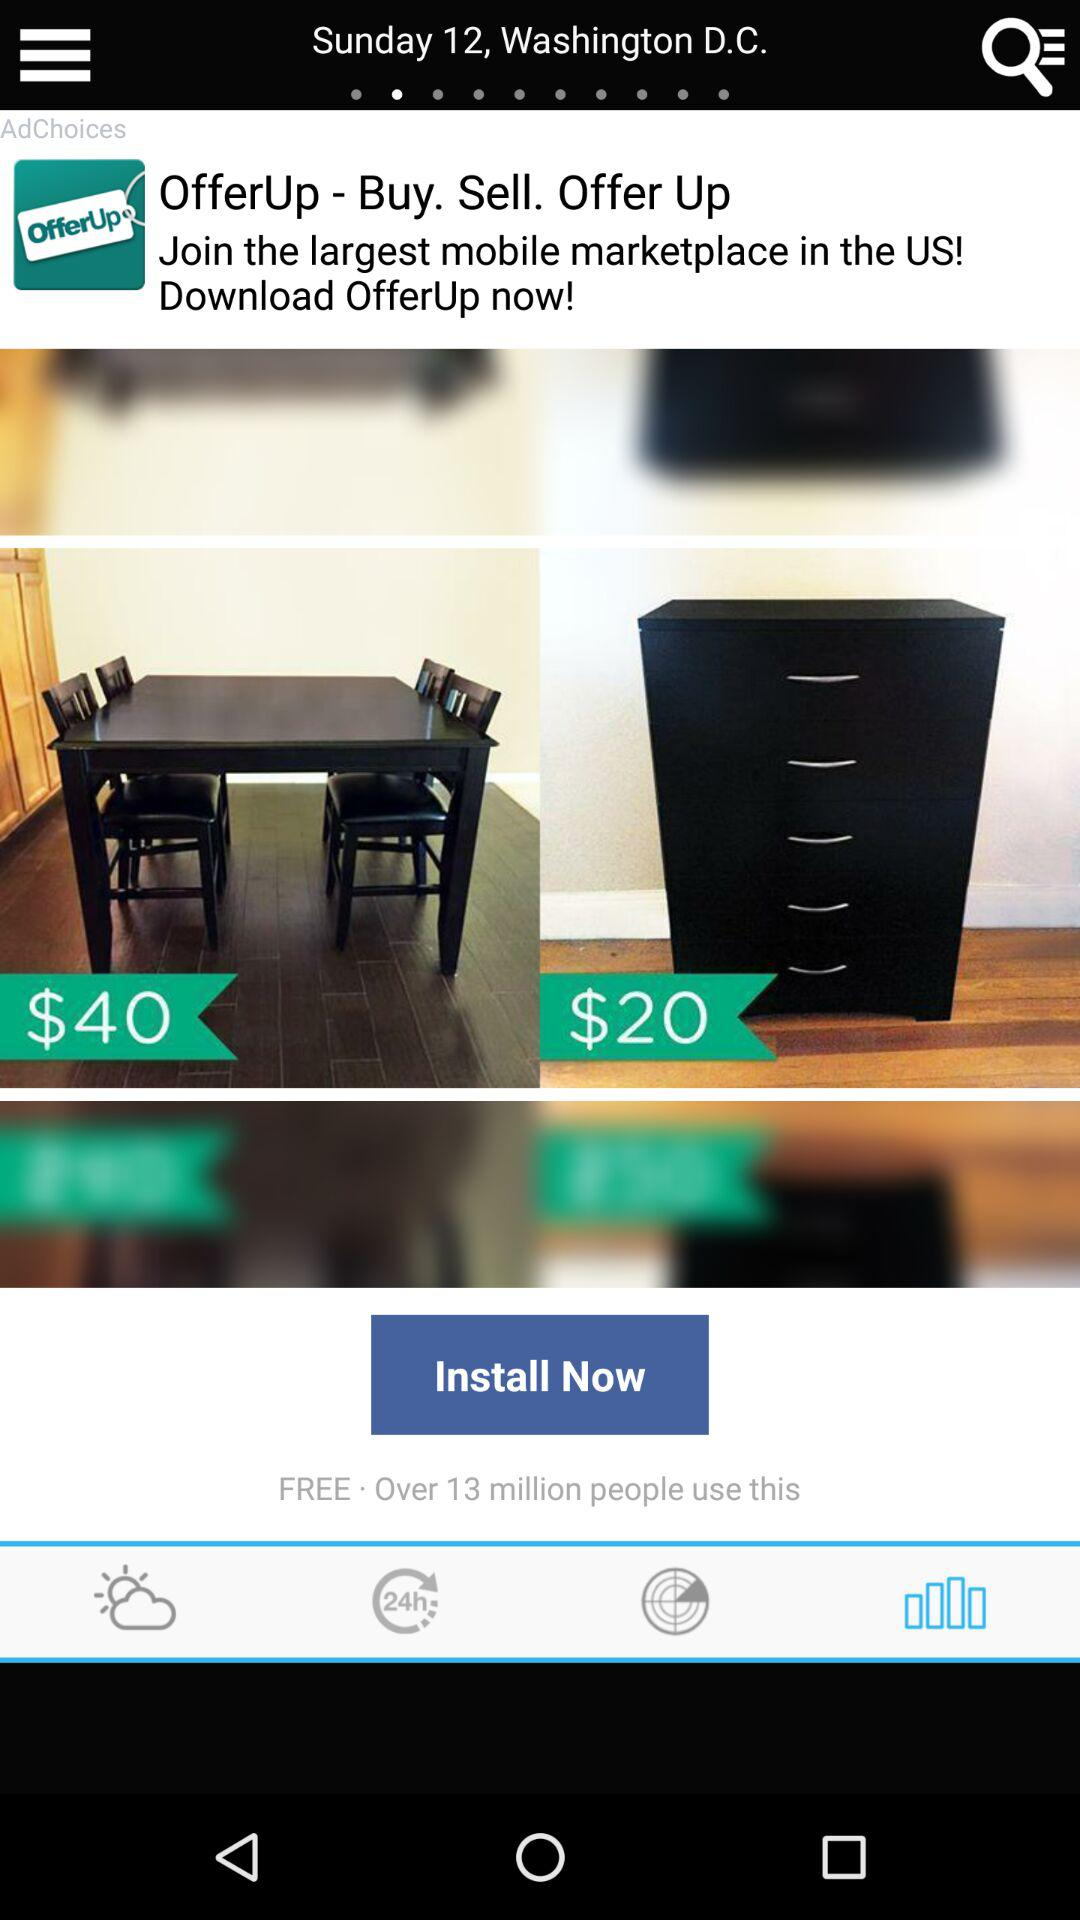What are the shown date and place? The shown date and place are Sunday, the 12th and Washington D.C., respectively. 